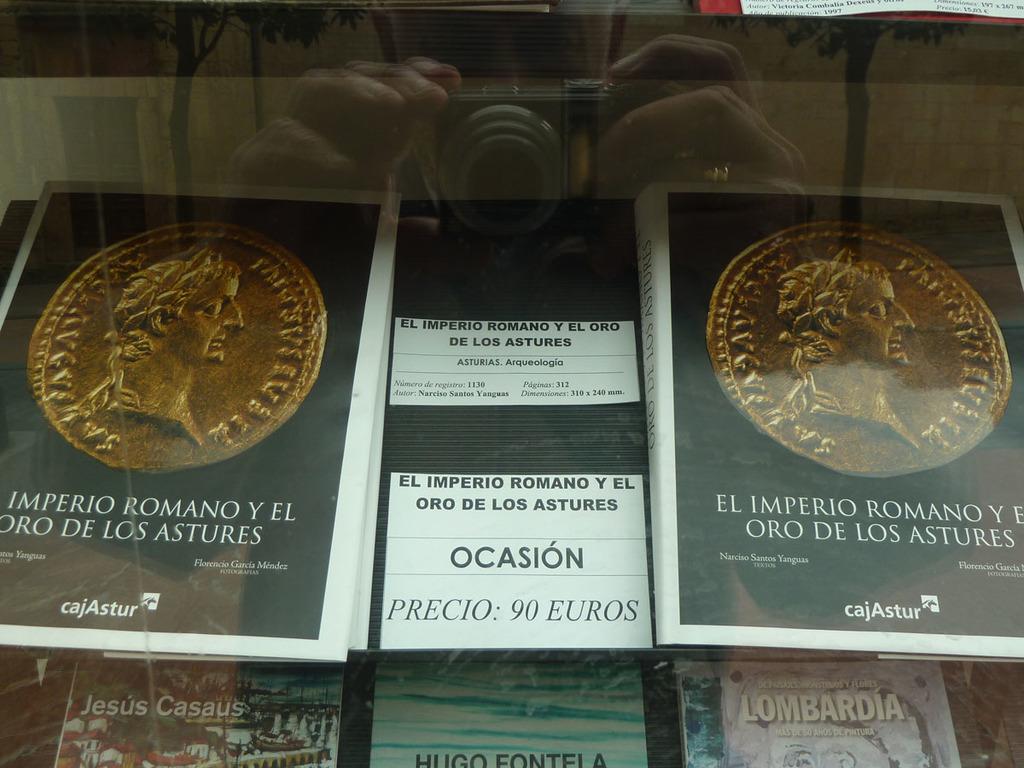How much do they cost?
Your response must be concise. 90 euros. 